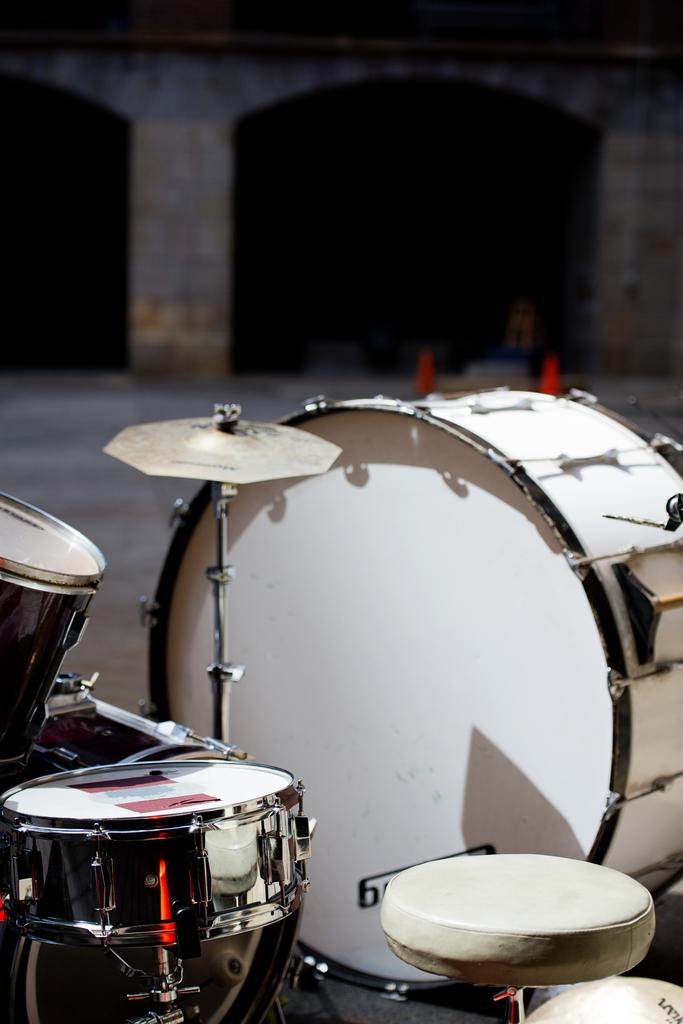What objects are in the foreground of the image? There are musical instruments in the foreground of the image. What type of structure can be seen in the background of the image? There is a building in the background of the image. What safety features are visible in the image? There are safety poles visible in the image. What type of feather can be seen in the image? There is no feather present in the image. What degree of difficulty is required to play the musical instruments in the image? The provided facts do not mention the difficulty level of playing the musical instruments, so it cannot be determined from the image. 